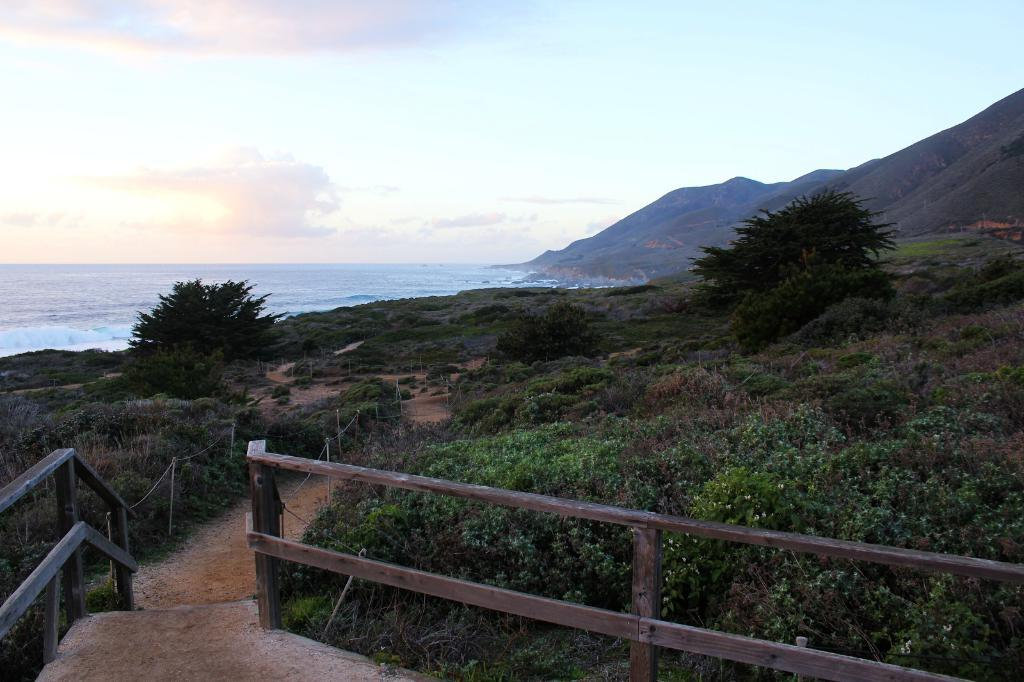What type of natural feature can be seen in the image? There is an ocean in the image. What other natural features are present in the image? There are mountains, trees, plants, and land covered with grass in the image. Can you describe the sky in the image? The sky is blue with clouds. What man-made structure is visible in the image? There is a railing in the image. How does the cactus in the image express regret? There is no cactus present in the image, and therefore it cannot express any emotions. 